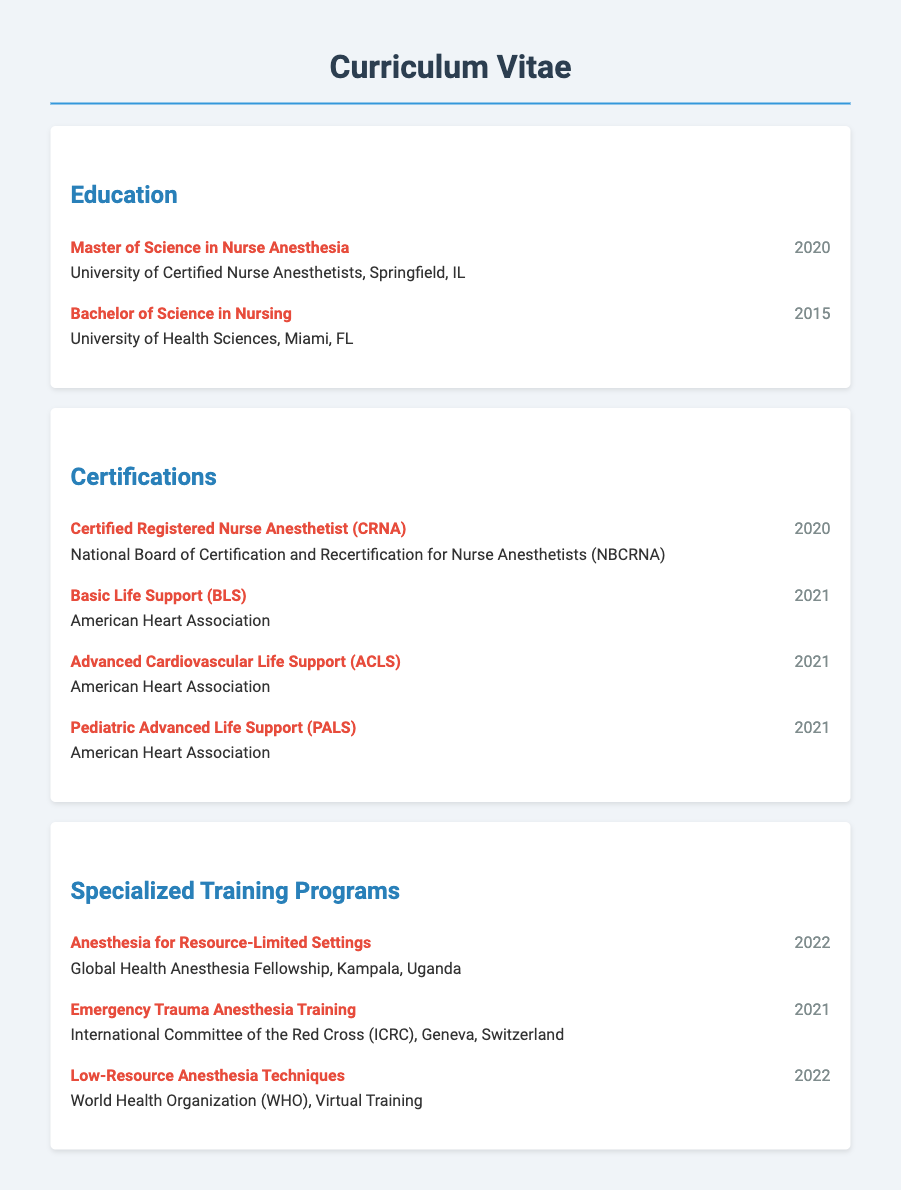what degree was obtained in 2020? The degree obtained in 2020 is listed in the Education section, which is the Master of Science in Nurse Anesthesia.
Answer: Master of Science in Nurse Anesthesia when did the nurse obtain their Bachelor of Science in Nursing? The date for the Bachelor of Science in Nursing can be found in the Education section, noting the year it was earned.
Answer: 2015 who issued the certification for Certified Registered Nurse Anesthetist? The issuing body for the CRNA certification is specified under the Certifications section of the document.
Answer: National Board of Certification and Recertification for Nurse Anesthetists what specialized training program was completed in 2022? The specialized training program completed in 2022 can be found in the Specialized Training Programs section of the document.
Answer: Anesthesia for Resource-Limited Settings what certification is required for Pediatric Advanced Life Support? The certification for Pediatric Advanced Life Support is detailed in the Certifications section, including who provides it.
Answer: American Heart Association how many specialized training programs are listed? The total number of specialized training programs can be determined by counting the entries listed in the corresponding section.
Answer: 3 what is the location of the Global Health Anesthesia Fellowship? The location of the fellowship is noted in the Specialized Training Programs section of the CV.
Answer: Kampala, Uganda which American Heart Association certification was acquired last? The order in which certifications were acquired is detailed in the Certifications section, indicating which one was the last listed.
Answer: Pediatric Advanced Life Support 